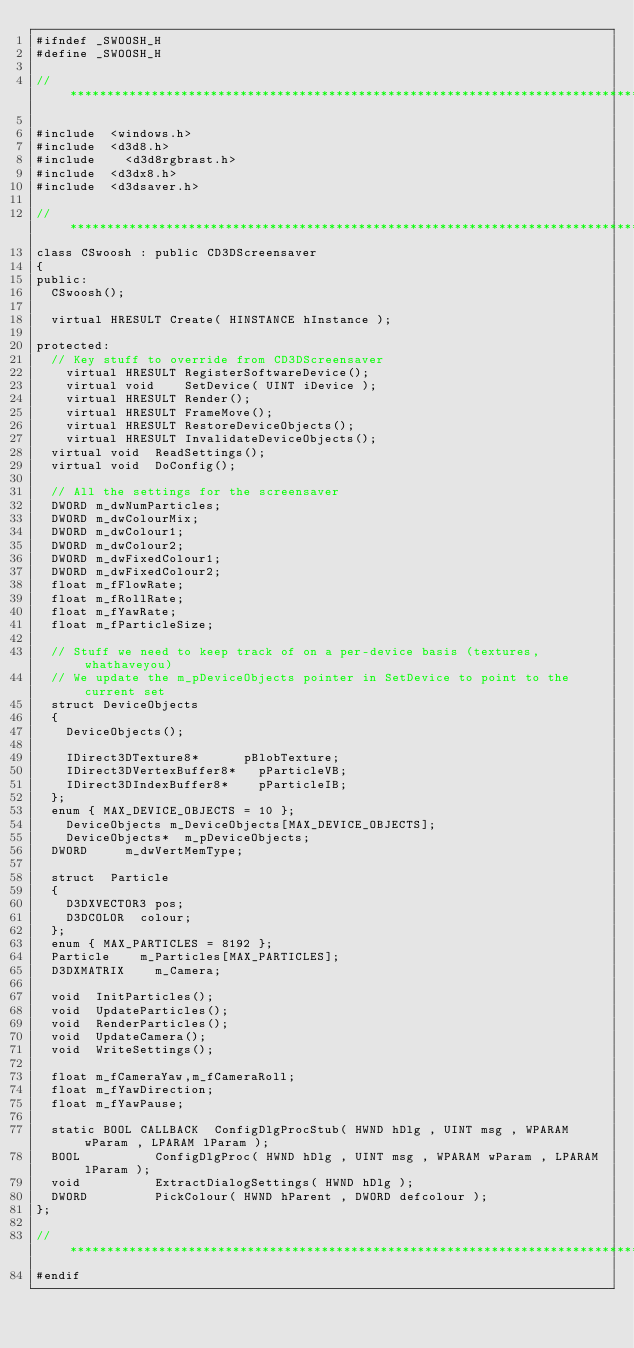Convert code to text. <code><loc_0><loc_0><loc_500><loc_500><_C_>#ifndef	_SWOOSH_H
#define	_SWOOSH_H

//**********************************************************************************

#include	<windows.h>
#include	<d3d8.h>
#include    <d3d8rgbrast.h>
#include	<d3dx8.h>
#include	<d3dsaver.h>

//**********************************************************************************
class	CSwoosh : public CD3DScreensaver
{
public:
	CSwoosh();

	virtual	HRESULT	Create( HINSTANCE hInstance );

protected:
	// Key stuff to override from CD3DScreensaver
    virtual HRESULT RegisterSoftwareDevice();
    virtual void    SetDevice( UINT iDevice );
    virtual HRESULT Render();
    virtual HRESULT FrameMove();
    virtual HRESULT RestoreDeviceObjects();
    virtual HRESULT InvalidateDeviceObjects();
	virtual	void	ReadSettings();
	virtual	void	DoConfig();

	// All the settings for the screensaver
	DWORD	m_dwNumParticles;
	DWORD	m_dwColourMix;
	DWORD	m_dwColour1;
	DWORD	m_dwColour2;
	DWORD	m_dwFixedColour1;
	DWORD	m_dwFixedColour2;
	float	m_fFlowRate;
	float	m_fRollRate;
	float	m_fYawRate;
	float	m_fParticleSize;

	// Stuff we need to keep track of on a per-device basis (textures, whathaveyou)
	// We update the m_pDeviceObjects pointer in SetDevice to point to the current set
	struct DeviceObjects
	{
		DeviceObjects();

		IDirect3DTexture8*			pBlobTexture;
		IDirect3DVertexBuffer8*		pParticleVB;
		IDirect3DIndexBuffer8*		pParticleIB;
	};
	enum { MAX_DEVICE_OBJECTS = 10 };
    DeviceObjects	m_DeviceObjects[MAX_DEVICE_OBJECTS];
    DeviceObjects*	m_pDeviceObjects;
	DWORD			m_dwVertMemType;

	struct	Particle
	{
		D3DXVECTOR3	pos;
		D3DCOLOR	colour;
	};
	enum { MAX_PARTICLES = 8192 };
	Particle		m_Particles[MAX_PARTICLES];
	D3DXMATRIX		m_Camera;

	void	InitParticles();
	void	UpdateParticles();
	void	RenderParticles();
	void	UpdateCamera();
	void	WriteSettings();

	float	m_fCameraYaw,m_fCameraRoll;
	float	m_fYawDirection;
	float	m_fYawPause;

	static BOOL CALLBACK	ConfigDlgProcStub( HWND hDlg , UINT msg , WPARAM wParam , LPARAM lParam );
	BOOL					ConfigDlgProc( HWND hDlg , UINT msg , WPARAM wParam , LPARAM lParam );
	void					ExtractDialogSettings( HWND hDlg );
	DWORD					PickColour( HWND hParent , DWORD defcolour );
};

//**********************************************************************************
#endif</code> 